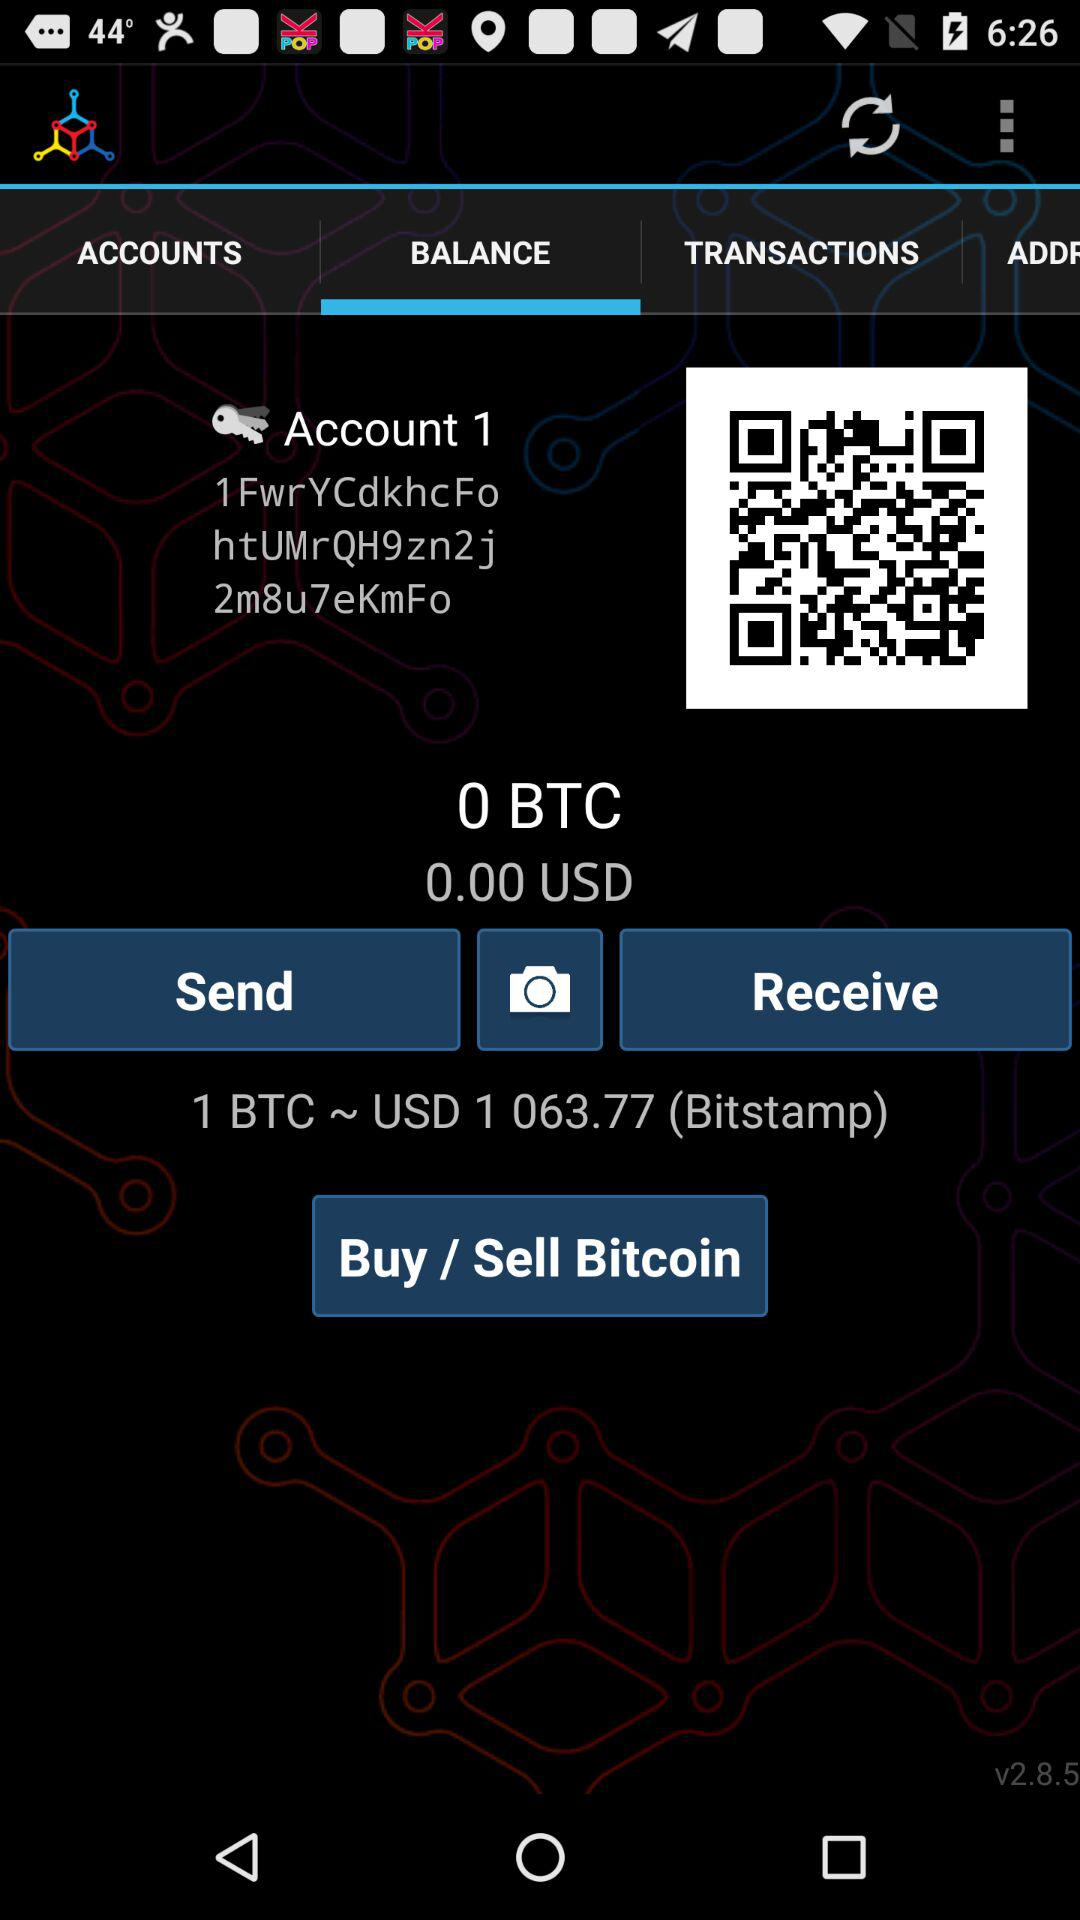How much money is in the account? The money in the account is 0.00 USD. 